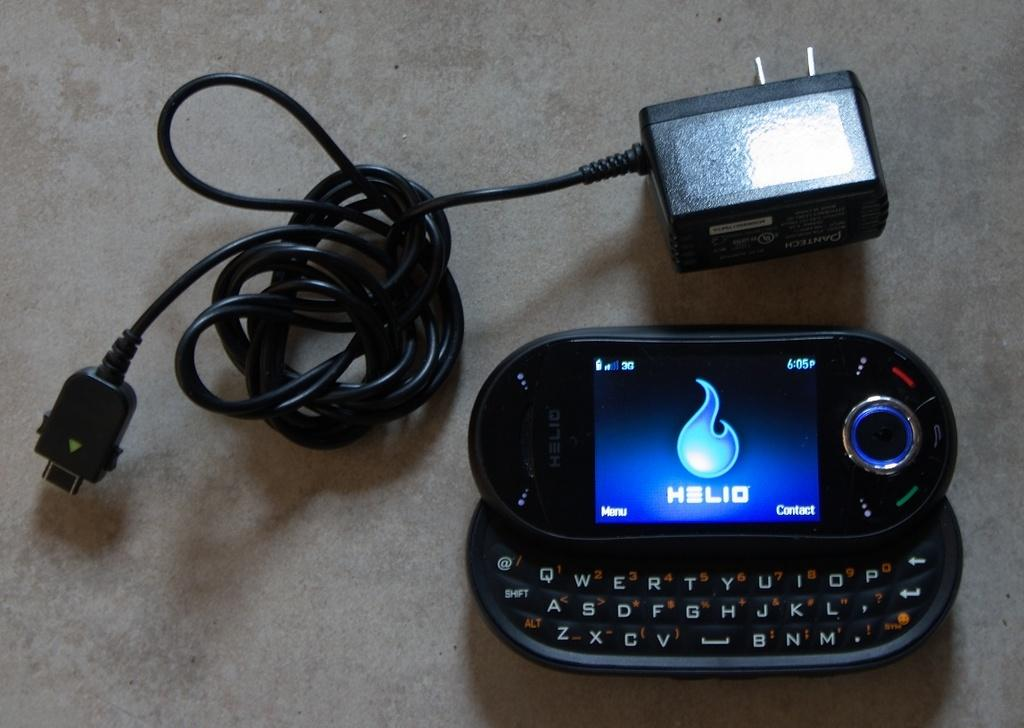What electronic device is visible in the image? There is a mobile phone in the image. What is used to provide power to the mobile phone? There is a charger in the image. How many eyes does the stick have in the image? There is no stick present in the image, and therefore no eyes can be observed. 